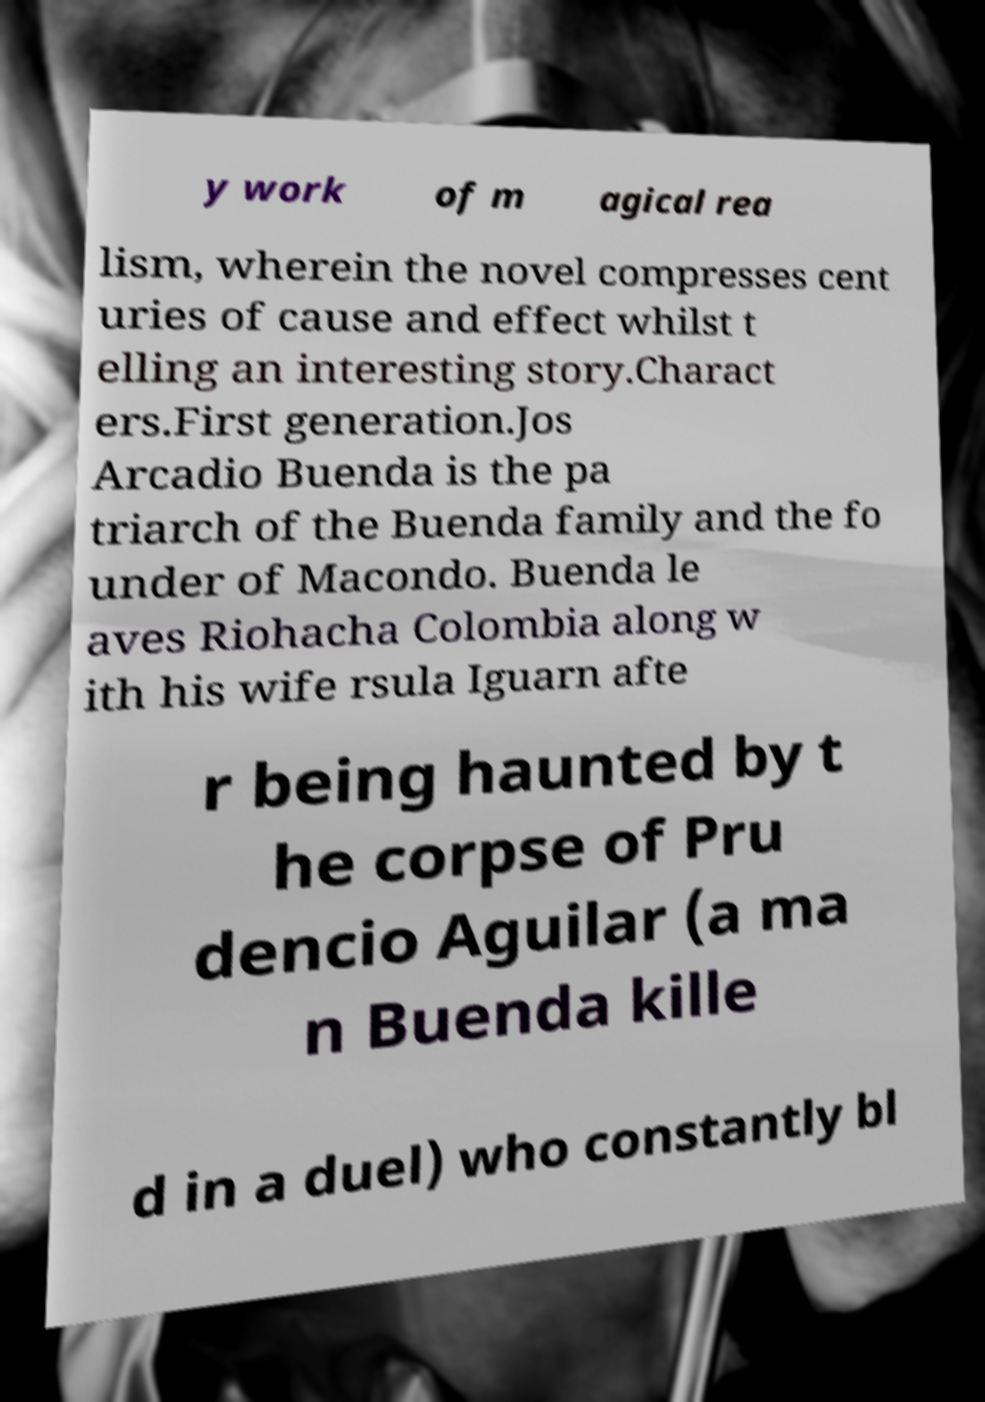Please read and relay the text visible in this image. What does it say? y work of m agical rea lism, wherein the novel compresses cent uries of cause and effect whilst t elling an interesting story.Charact ers.First generation.Jos Arcadio Buenda is the pa triarch of the Buenda family and the fo under of Macondo. Buenda le aves Riohacha Colombia along w ith his wife rsula Iguarn afte r being haunted by t he corpse of Pru dencio Aguilar (a ma n Buenda kille d in a duel) who constantly bl 